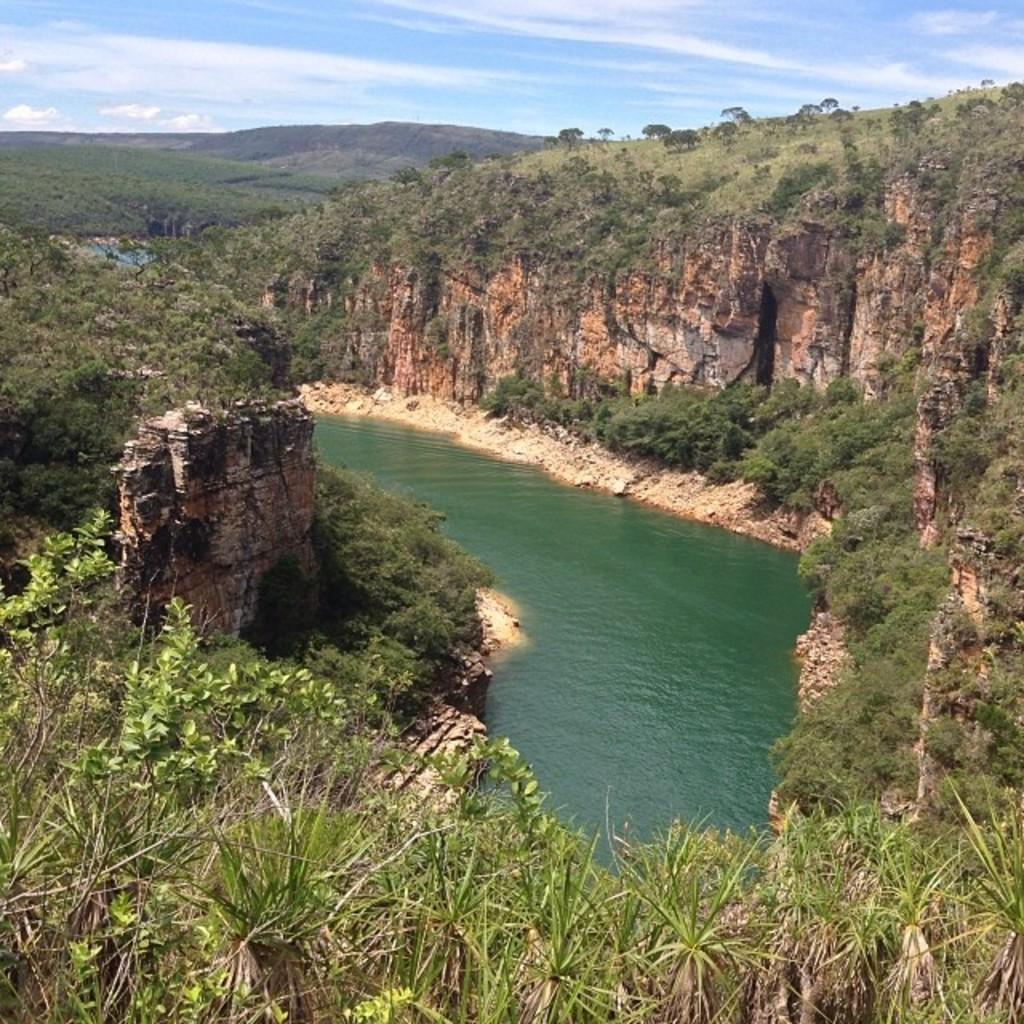Could you give a brief overview of what you see in this image? In the picture we can see the water surface around it, we can see the hills covered with grass and plants. In the background, we can see the hills and the sky with clouds. 